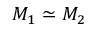<formula> <loc_0><loc_0><loc_500><loc_500>M _ { 1 } \simeq M _ { 2 }</formula> 